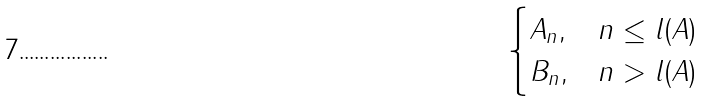Convert formula to latex. <formula><loc_0><loc_0><loc_500><loc_500>\begin{cases} A _ { n } , & n \leq l ( A ) \\ B _ { n } , & n > l ( A ) \end{cases}</formula> 